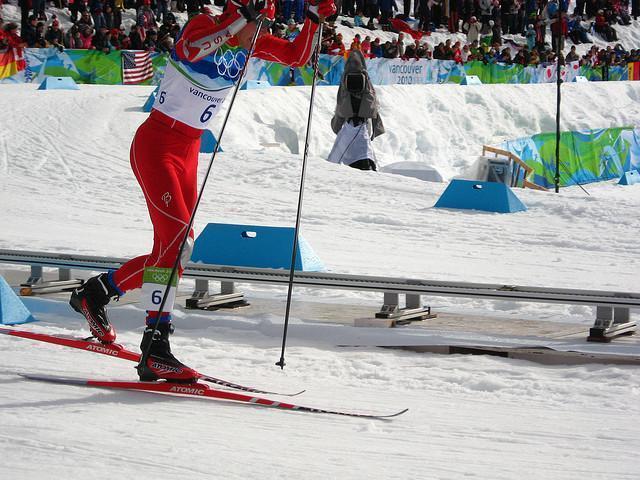How many people are there?
Give a very brief answer. 3. How many red cars can be seen to the right of the bus?
Give a very brief answer. 0. 